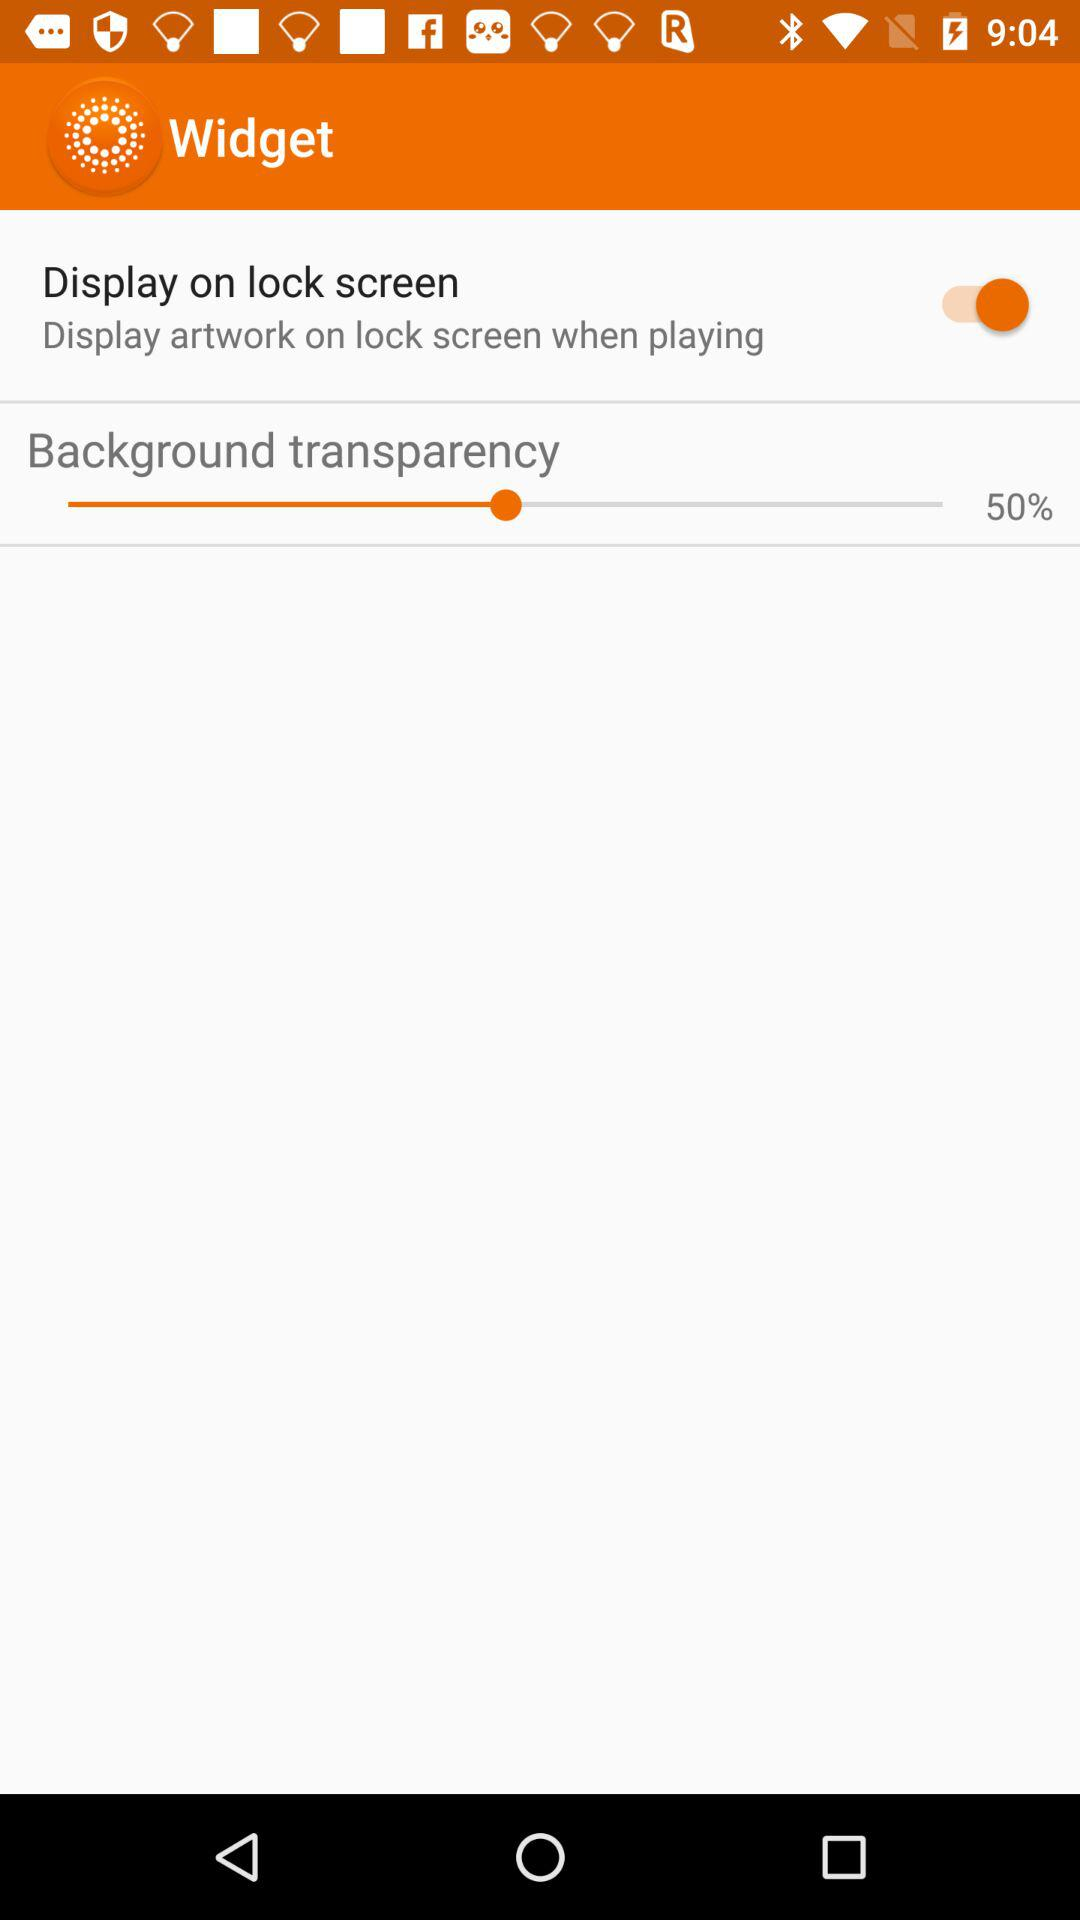What's the percentage of background transparency? The percentage of background transparency is 50. 